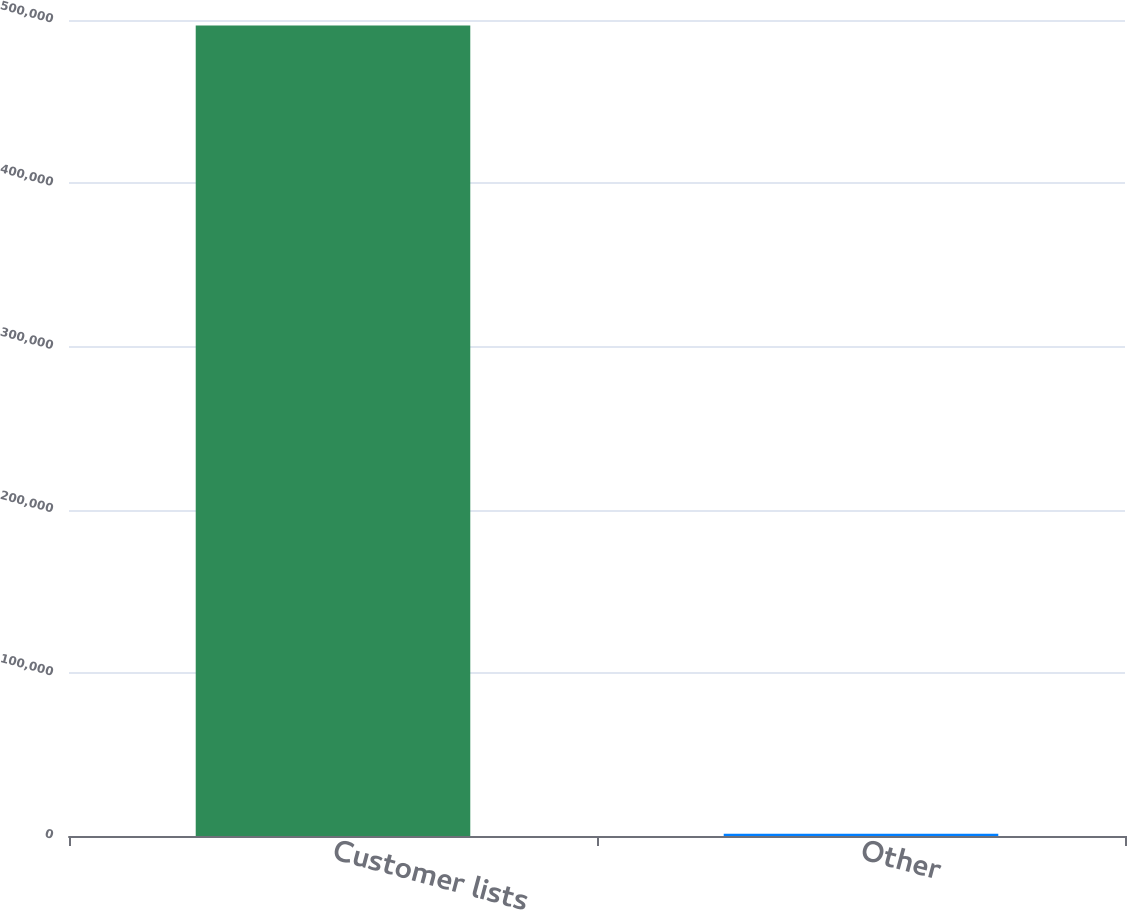Convert chart to OTSL. <chart><loc_0><loc_0><loc_500><loc_500><bar_chart><fcel>Customer lists<fcel>Other<nl><fcel>496624<fcel>1450<nl></chart> 